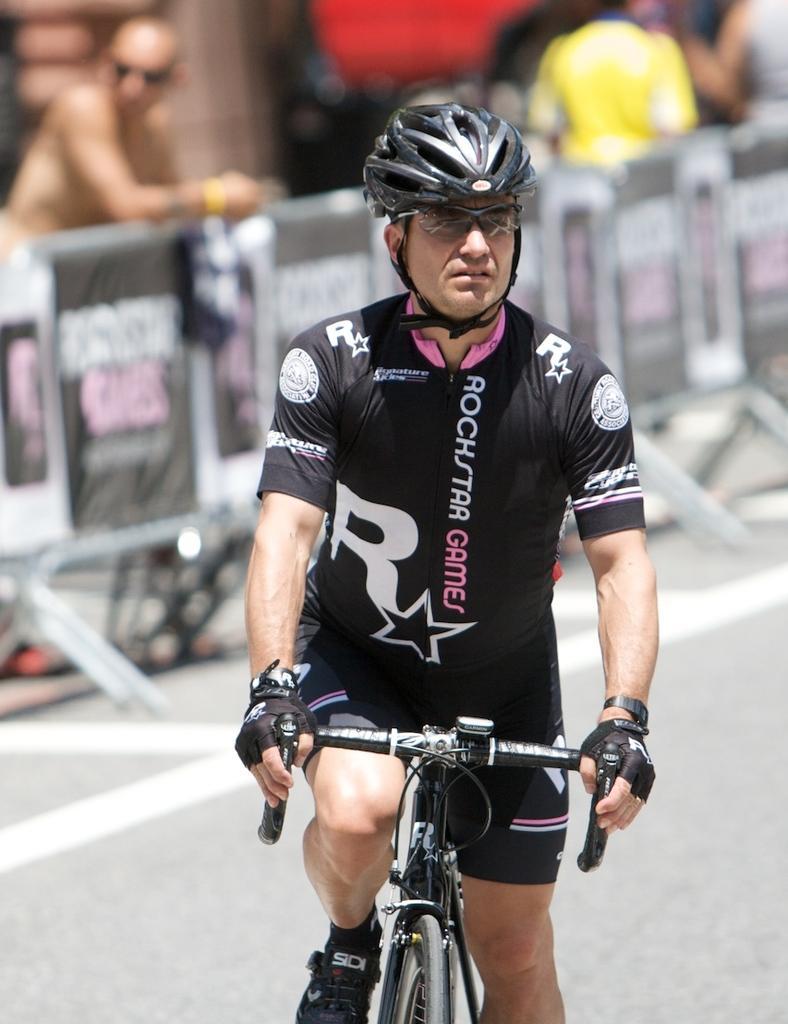Can you describe this image briefly? There is a man sitting and riding bicycle on the road and wore helmet and glasses. In the background it is blurry and we can see people. 